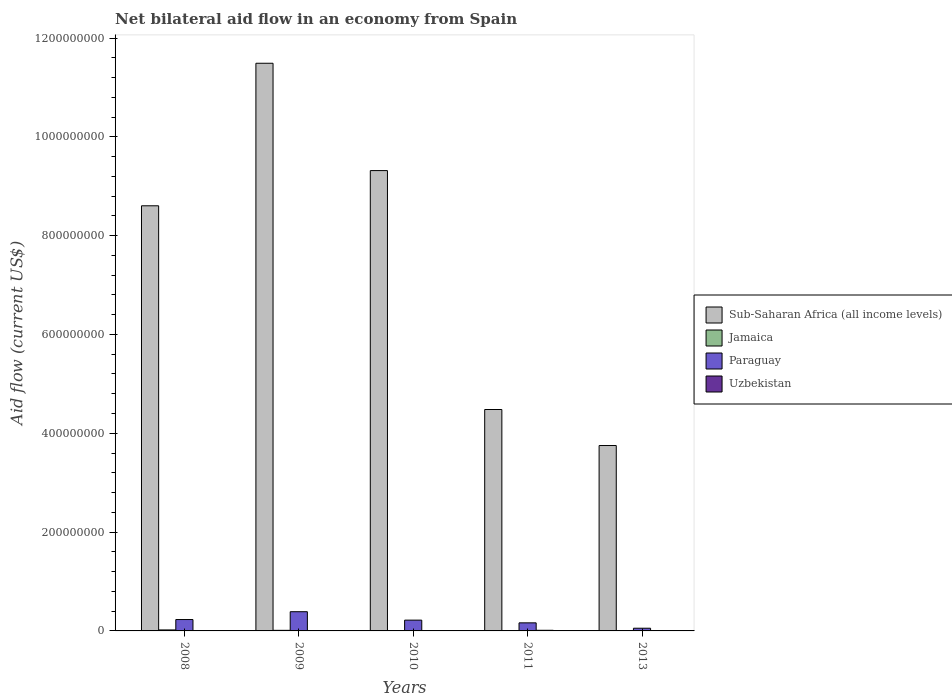Are the number of bars per tick equal to the number of legend labels?
Your response must be concise. Yes. Are the number of bars on each tick of the X-axis equal?
Offer a very short reply. Yes. What is the net bilateral aid flow in Uzbekistan in 2008?
Offer a terse response. 3.60e+05. Across all years, what is the maximum net bilateral aid flow in Paraguay?
Provide a succinct answer. 3.89e+07. Across all years, what is the minimum net bilateral aid flow in Paraguay?
Keep it short and to the point. 5.44e+06. In which year was the net bilateral aid flow in Uzbekistan minimum?
Offer a terse response. 2013. What is the total net bilateral aid flow in Jamaica in the graph?
Your answer should be compact. 4.17e+06. What is the difference between the net bilateral aid flow in Uzbekistan in 2008 and that in 2010?
Provide a succinct answer. 1.30e+05. What is the difference between the net bilateral aid flow in Uzbekistan in 2011 and the net bilateral aid flow in Sub-Saharan Africa (all income levels) in 2010?
Keep it short and to the point. -9.30e+08. What is the average net bilateral aid flow in Paraguay per year?
Make the answer very short. 2.11e+07. In the year 2011, what is the difference between the net bilateral aid flow in Uzbekistan and net bilateral aid flow in Paraguay?
Your response must be concise. -1.51e+07. What is the ratio of the net bilateral aid flow in Sub-Saharan Africa (all income levels) in 2009 to that in 2011?
Keep it short and to the point. 2.56. Is the net bilateral aid flow in Paraguay in 2011 less than that in 2013?
Offer a very short reply. No. Is the difference between the net bilateral aid flow in Uzbekistan in 2009 and 2011 greater than the difference between the net bilateral aid flow in Paraguay in 2009 and 2011?
Keep it short and to the point. No. What is the difference between the highest and the second highest net bilateral aid flow in Paraguay?
Ensure brevity in your answer.  1.59e+07. What is the difference between the highest and the lowest net bilateral aid flow in Paraguay?
Offer a very short reply. 3.34e+07. What does the 4th bar from the left in 2010 represents?
Your answer should be compact. Uzbekistan. What does the 1st bar from the right in 2009 represents?
Offer a very short reply. Uzbekistan. How many bars are there?
Make the answer very short. 20. Are all the bars in the graph horizontal?
Offer a very short reply. No. Are the values on the major ticks of Y-axis written in scientific E-notation?
Give a very brief answer. No. Does the graph contain grids?
Provide a succinct answer. No. How many legend labels are there?
Provide a succinct answer. 4. How are the legend labels stacked?
Make the answer very short. Vertical. What is the title of the graph?
Make the answer very short. Net bilateral aid flow in an economy from Spain. What is the label or title of the X-axis?
Give a very brief answer. Years. What is the Aid flow (current US$) of Sub-Saharan Africa (all income levels) in 2008?
Make the answer very short. 8.60e+08. What is the Aid flow (current US$) in Jamaica in 2008?
Ensure brevity in your answer.  2.02e+06. What is the Aid flow (current US$) in Paraguay in 2008?
Provide a succinct answer. 2.30e+07. What is the Aid flow (current US$) of Uzbekistan in 2008?
Keep it short and to the point. 3.60e+05. What is the Aid flow (current US$) in Sub-Saharan Africa (all income levels) in 2009?
Offer a very short reply. 1.15e+09. What is the Aid flow (current US$) in Jamaica in 2009?
Your answer should be compact. 1.19e+06. What is the Aid flow (current US$) in Paraguay in 2009?
Keep it short and to the point. 3.89e+07. What is the Aid flow (current US$) in Uzbekistan in 2009?
Give a very brief answer. 6.60e+05. What is the Aid flow (current US$) in Sub-Saharan Africa (all income levels) in 2010?
Provide a short and direct response. 9.32e+08. What is the Aid flow (current US$) of Jamaica in 2010?
Provide a short and direct response. 5.10e+05. What is the Aid flow (current US$) in Paraguay in 2010?
Provide a short and direct response. 2.18e+07. What is the Aid flow (current US$) of Sub-Saharan Africa (all income levels) in 2011?
Offer a very short reply. 4.48e+08. What is the Aid flow (current US$) in Paraguay in 2011?
Keep it short and to the point. 1.63e+07. What is the Aid flow (current US$) of Uzbekistan in 2011?
Your response must be concise. 1.27e+06. What is the Aid flow (current US$) in Sub-Saharan Africa (all income levels) in 2013?
Provide a short and direct response. 3.75e+08. What is the Aid flow (current US$) in Jamaica in 2013?
Your answer should be compact. 2.00e+05. What is the Aid flow (current US$) in Paraguay in 2013?
Give a very brief answer. 5.44e+06. What is the Aid flow (current US$) in Uzbekistan in 2013?
Provide a short and direct response. 3.00e+04. Across all years, what is the maximum Aid flow (current US$) in Sub-Saharan Africa (all income levels)?
Your response must be concise. 1.15e+09. Across all years, what is the maximum Aid flow (current US$) in Jamaica?
Your answer should be compact. 2.02e+06. Across all years, what is the maximum Aid flow (current US$) of Paraguay?
Offer a very short reply. 3.89e+07. Across all years, what is the maximum Aid flow (current US$) in Uzbekistan?
Make the answer very short. 1.27e+06. Across all years, what is the minimum Aid flow (current US$) in Sub-Saharan Africa (all income levels)?
Make the answer very short. 3.75e+08. Across all years, what is the minimum Aid flow (current US$) in Paraguay?
Your answer should be very brief. 5.44e+06. What is the total Aid flow (current US$) of Sub-Saharan Africa (all income levels) in the graph?
Ensure brevity in your answer.  3.76e+09. What is the total Aid flow (current US$) of Jamaica in the graph?
Your answer should be very brief. 4.17e+06. What is the total Aid flow (current US$) in Paraguay in the graph?
Make the answer very short. 1.06e+08. What is the total Aid flow (current US$) of Uzbekistan in the graph?
Provide a short and direct response. 2.55e+06. What is the difference between the Aid flow (current US$) of Sub-Saharan Africa (all income levels) in 2008 and that in 2009?
Provide a short and direct response. -2.88e+08. What is the difference between the Aid flow (current US$) of Jamaica in 2008 and that in 2009?
Your answer should be very brief. 8.30e+05. What is the difference between the Aid flow (current US$) of Paraguay in 2008 and that in 2009?
Ensure brevity in your answer.  -1.59e+07. What is the difference between the Aid flow (current US$) of Sub-Saharan Africa (all income levels) in 2008 and that in 2010?
Your response must be concise. -7.13e+07. What is the difference between the Aid flow (current US$) in Jamaica in 2008 and that in 2010?
Give a very brief answer. 1.51e+06. What is the difference between the Aid flow (current US$) of Paraguay in 2008 and that in 2010?
Offer a terse response. 1.19e+06. What is the difference between the Aid flow (current US$) in Sub-Saharan Africa (all income levels) in 2008 and that in 2011?
Offer a terse response. 4.12e+08. What is the difference between the Aid flow (current US$) of Jamaica in 2008 and that in 2011?
Give a very brief answer. 1.77e+06. What is the difference between the Aid flow (current US$) in Paraguay in 2008 and that in 2011?
Ensure brevity in your answer.  6.69e+06. What is the difference between the Aid flow (current US$) in Uzbekistan in 2008 and that in 2011?
Provide a succinct answer. -9.10e+05. What is the difference between the Aid flow (current US$) in Sub-Saharan Africa (all income levels) in 2008 and that in 2013?
Your response must be concise. 4.85e+08. What is the difference between the Aid flow (current US$) of Jamaica in 2008 and that in 2013?
Your answer should be compact. 1.82e+06. What is the difference between the Aid flow (current US$) in Paraguay in 2008 and that in 2013?
Provide a succinct answer. 1.76e+07. What is the difference between the Aid flow (current US$) of Sub-Saharan Africa (all income levels) in 2009 and that in 2010?
Offer a very short reply. 2.17e+08. What is the difference between the Aid flow (current US$) of Jamaica in 2009 and that in 2010?
Your answer should be very brief. 6.80e+05. What is the difference between the Aid flow (current US$) of Paraguay in 2009 and that in 2010?
Offer a terse response. 1.70e+07. What is the difference between the Aid flow (current US$) of Sub-Saharan Africa (all income levels) in 2009 and that in 2011?
Offer a very short reply. 7.01e+08. What is the difference between the Aid flow (current US$) in Jamaica in 2009 and that in 2011?
Your answer should be very brief. 9.40e+05. What is the difference between the Aid flow (current US$) in Paraguay in 2009 and that in 2011?
Provide a short and direct response. 2.26e+07. What is the difference between the Aid flow (current US$) of Uzbekistan in 2009 and that in 2011?
Offer a terse response. -6.10e+05. What is the difference between the Aid flow (current US$) in Sub-Saharan Africa (all income levels) in 2009 and that in 2013?
Ensure brevity in your answer.  7.74e+08. What is the difference between the Aid flow (current US$) of Jamaica in 2009 and that in 2013?
Provide a short and direct response. 9.90e+05. What is the difference between the Aid flow (current US$) in Paraguay in 2009 and that in 2013?
Keep it short and to the point. 3.34e+07. What is the difference between the Aid flow (current US$) in Uzbekistan in 2009 and that in 2013?
Make the answer very short. 6.30e+05. What is the difference between the Aid flow (current US$) in Sub-Saharan Africa (all income levels) in 2010 and that in 2011?
Your response must be concise. 4.84e+08. What is the difference between the Aid flow (current US$) in Jamaica in 2010 and that in 2011?
Offer a terse response. 2.60e+05. What is the difference between the Aid flow (current US$) of Paraguay in 2010 and that in 2011?
Make the answer very short. 5.50e+06. What is the difference between the Aid flow (current US$) of Uzbekistan in 2010 and that in 2011?
Keep it short and to the point. -1.04e+06. What is the difference between the Aid flow (current US$) in Sub-Saharan Africa (all income levels) in 2010 and that in 2013?
Your answer should be compact. 5.56e+08. What is the difference between the Aid flow (current US$) in Jamaica in 2010 and that in 2013?
Make the answer very short. 3.10e+05. What is the difference between the Aid flow (current US$) in Paraguay in 2010 and that in 2013?
Your response must be concise. 1.64e+07. What is the difference between the Aid flow (current US$) in Sub-Saharan Africa (all income levels) in 2011 and that in 2013?
Your answer should be compact. 7.29e+07. What is the difference between the Aid flow (current US$) of Jamaica in 2011 and that in 2013?
Make the answer very short. 5.00e+04. What is the difference between the Aid flow (current US$) in Paraguay in 2011 and that in 2013?
Your answer should be compact. 1.09e+07. What is the difference between the Aid flow (current US$) in Uzbekistan in 2011 and that in 2013?
Your answer should be compact. 1.24e+06. What is the difference between the Aid flow (current US$) in Sub-Saharan Africa (all income levels) in 2008 and the Aid flow (current US$) in Jamaica in 2009?
Offer a terse response. 8.59e+08. What is the difference between the Aid flow (current US$) of Sub-Saharan Africa (all income levels) in 2008 and the Aid flow (current US$) of Paraguay in 2009?
Your answer should be compact. 8.22e+08. What is the difference between the Aid flow (current US$) in Sub-Saharan Africa (all income levels) in 2008 and the Aid flow (current US$) in Uzbekistan in 2009?
Provide a short and direct response. 8.60e+08. What is the difference between the Aid flow (current US$) in Jamaica in 2008 and the Aid flow (current US$) in Paraguay in 2009?
Keep it short and to the point. -3.69e+07. What is the difference between the Aid flow (current US$) of Jamaica in 2008 and the Aid flow (current US$) of Uzbekistan in 2009?
Provide a short and direct response. 1.36e+06. What is the difference between the Aid flow (current US$) in Paraguay in 2008 and the Aid flow (current US$) in Uzbekistan in 2009?
Provide a succinct answer. 2.24e+07. What is the difference between the Aid flow (current US$) in Sub-Saharan Africa (all income levels) in 2008 and the Aid flow (current US$) in Jamaica in 2010?
Your response must be concise. 8.60e+08. What is the difference between the Aid flow (current US$) of Sub-Saharan Africa (all income levels) in 2008 and the Aid flow (current US$) of Paraguay in 2010?
Offer a terse response. 8.39e+08. What is the difference between the Aid flow (current US$) of Sub-Saharan Africa (all income levels) in 2008 and the Aid flow (current US$) of Uzbekistan in 2010?
Offer a terse response. 8.60e+08. What is the difference between the Aid flow (current US$) of Jamaica in 2008 and the Aid flow (current US$) of Paraguay in 2010?
Provide a short and direct response. -1.98e+07. What is the difference between the Aid flow (current US$) in Jamaica in 2008 and the Aid flow (current US$) in Uzbekistan in 2010?
Offer a terse response. 1.79e+06. What is the difference between the Aid flow (current US$) of Paraguay in 2008 and the Aid flow (current US$) of Uzbekistan in 2010?
Your answer should be compact. 2.28e+07. What is the difference between the Aid flow (current US$) in Sub-Saharan Africa (all income levels) in 2008 and the Aid flow (current US$) in Jamaica in 2011?
Provide a short and direct response. 8.60e+08. What is the difference between the Aid flow (current US$) in Sub-Saharan Africa (all income levels) in 2008 and the Aid flow (current US$) in Paraguay in 2011?
Your answer should be compact. 8.44e+08. What is the difference between the Aid flow (current US$) of Sub-Saharan Africa (all income levels) in 2008 and the Aid flow (current US$) of Uzbekistan in 2011?
Offer a terse response. 8.59e+08. What is the difference between the Aid flow (current US$) of Jamaica in 2008 and the Aid flow (current US$) of Paraguay in 2011?
Provide a succinct answer. -1.43e+07. What is the difference between the Aid flow (current US$) of Jamaica in 2008 and the Aid flow (current US$) of Uzbekistan in 2011?
Your answer should be very brief. 7.50e+05. What is the difference between the Aid flow (current US$) in Paraguay in 2008 and the Aid flow (current US$) in Uzbekistan in 2011?
Keep it short and to the point. 2.18e+07. What is the difference between the Aid flow (current US$) of Sub-Saharan Africa (all income levels) in 2008 and the Aid flow (current US$) of Jamaica in 2013?
Your response must be concise. 8.60e+08. What is the difference between the Aid flow (current US$) in Sub-Saharan Africa (all income levels) in 2008 and the Aid flow (current US$) in Paraguay in 2013?
Provide a succinct answer. 8.55e+08. What is the difference between the Aid flow (current US$) of Sub-Saharan Africa (all income levels) in 2008 and the Aid flow (current US$) of Uzbekistan in 2013?
Offer a terse response. 8.60e+08. What is the difference between the Aid flow (current US$) in Jamaica in 2008 and the Aid flow (current US$) in Paraguay in 2013?
Ensure brevity in your answer.  -3.42e+06. What is the difference between the Aid flow (current US$) of Jamaica in 2008 and the Aid flow (current US$) of Uzbekistan in 2013?
Ensure brevity in your answer.  1.99e+06. What is the difference between the Aid flow (current US$) of Paraguay in 2008 and the Aid flow (current US$) of Uzbekistan in 2013?
Your answer should be compact. 2.30e+07. What is the difference between the Aid flow (current US$) of Sub-Saharan Africa (all income levels) in 2009 and the Aid flow (current US$) of Jamaica in 2010?
Make the answer very short. 1.15e+09. What is the difference between the Aid flow (current US$) of Sub-Saharan Africa (all income levels) in 2009 and the Aid flow (current US$) of Paraguay in 2010?
Give a very brief answer. 1.13e+09. What is the difference between the Aid flow (current US$) in Sub-Saharan Africa (all income levels) in 2009 and the Aid flow (current US$) in Uzbekistan in 2010?
Ensure brevity in your answer.  1.15e+09. What is the difference between the Aid flow (current US$) of Jamaica in 2009 and the Aid flow (current US$) of Paraguay in 2010?
Your response must be concise. -2.06e+07. What is the difference between the Aid flow (current US$) in Jamaica in 2009 and the Aid flow (current US$) in Uzbekistan in 2010?
Keep it short and to the point. 9.60e+05. What is the difference between the Aid flow (current US$) of Paraguay in 2009 and the Aid flow (current US$) of Uzbekistan in 2010?
Keep it short and to the point. 3.87e+07. What is the difference between the Aid flow (current US$) of Sub-Saharan Africa (all income levels) in 2009 and the Aid flow (current US$) of Jamaica in 2011?
Provide a short and direct response. 1.15e+09. What is the difference between the Aid flow (current US$) of Sub-Saharan Africa (all income levels) in 2009 and the Aid flow (current US$) of Paraguay in 2011?
Keep it short and to the point. 1.13e+09. What is the difference between the Aid flow (current US$) in Sub-Saharan Africa (all income levels) in 2009 and the Aid flow (current US$) in Uzbekistan in 2011?
Offer a very short reply. 1.15e+09. What is the difference between the Aid flow (current US$) of Jamaica in 2009 and the Aid flow (current US$) of Paraguay in 2011?
Offer a terse response. -1.52e+07. What is the difference between the Aid flow (current US$) of Paraguay in 2009 and the Aid flow (current US$) of Uzbekistan in 2011?
Offer a very short reply. 3.76e+07. What is the difference between the Aid flow (current US$) in Sub-Saharan Africa (all income levels) in 2009 and the Aid flow (current US$) in Jamaica in 2013?
Give a very brief answer. 1.15e+09. What is the difference between the Aid flow (current US$) of Sub-Saharan Africa (all income levels) in 2009 and the Aid flow (current US$) of Paraguay in 2013?
Offer a terse response. 1.14e+09. What is the difference between the Aid flow (current US$) of Sub-Saharan Africa (all income levels) in 2009 and the Aid flow (current US$) of Uzbekistan in 2013?
Provide a short and direct response. 1.15e+09. What is the difference between the Aid flow (current US$) of Jamaica in 2009 and the Aid flow (current US$) of Paraguay in 2013?
Your response must be concise. -4.25e+06. What is the difference between the Aid flow (current US$) in Jamaica in 2009 and the Aid flow (current US$) in Uzbekistan in 2013?
Provide a succinct answer. 1.16e+06. What is the difference between the Aid flow (current US$) of Paraguay in 2009 and the Aid flow (current US$) of Uzbekistan in 2013?
Make the answer very short. 3.89e+07. What is the difference between the Aid flow (current US$) of Sub-Saharan Africa (all income levels) in 2010 and the Aid flow (current US$) of Jamaica in 2011?
Keep it short and to the point. 9.31e+08. What is the difference between the Aid flow (current US$) of Sub-Saharan Africa (all income levels) in 2010 and the Aid flow (current US$) of Paraguay in 2011?
Make the answer very short. 9.15e+08. What is the difference between the Aid flow (current US$) in Sub-Saharan Africa (all income levels) in 2010 and the Aid flow (current US$) in Uzbekistan in 2011?
Make the answer very short. 9.30e+08. What is the difference between the Aid flow (current US$) of Jamaica in 2010 and the Aid flow (current US$) of Paraguay in 2011?
Your answer should be very brief. -1.58e+07. What is the difference between the Aid flow (current US$) in Jamaica in 2010 and the Aid flow (current US$) in Uzbekistan in 2011?
Offer a very short reply. -7.60e+05. What is the difference between the Aid flow (current US$) in Paraguay in 2010 and the Aid flow (current US$) in Uzbekistan in 2011?
Offer a very short reply. 2.06e+07. What is the difference between the Aid flow (current US$) in Sub-Saharan Africa (all income levels) in 2010 and the Aid flow (current US$) in Jamaica in 2013?
Offer a very short reply. 9.32e+08. What is the difference between the Aid flow (current US$) of Sub-Saharan Africa (all income levels) in 2010 and the Aid flow (current US$) of Paraguay in 2013?
Offer a very short reply. 9.26e+08. What is the difference between the Aid flow (current US$) in Sub-Saharan Africa (all income levels) in 2010 and the Aid flow (current US$) in Uzbekistan in 2013?
Ensure brevity in your answer.  9.32e+08. What is the difference between the Aid flow (current US$) in Jamaica in 2010 and the Aid flow (current US$) in Paraguay in 2013?
Provide a short and direct response. -4.93e+06. What is the difference between the Aid flow (current US$) of Paraguay in 2010 and the Aid flow (current US$) of Uzbekistan in 2013?
Ensure brevity in your answer.  2.18e+07. What is the difference between the Aid flow (current US$) in Sub-Saharan Africa (all income levels) in 2011 and the Aid flow (current US$) in Jamaica in 2013?
Give a very brief answer. 4.48e+08. What is the difference between the Aid flow (current US$) of Sub-Saharan Africa (all income levels) in 2011 and the Aid flow (current US$) of Paraguay in 2013?
Your answer should be compact. 4.43e+08. What is the difference between the Aid flow (current US$) of Sub-Saharan Africa (all income levels) in 2011 and the Aid flow (current US$) of Uzbekistan in 2013?
Keep it short and to the point. 4.48e+08. What is the difference between the Aid flow (current US$) of Jamaica in 2011 and the Aid flow (current US$) of Paraguay in 2013?
Provide a short and direct response. -5.19e+06. What is the difference between the Aid flow (current US$) of Jamaica in 2011 and the Aid flow (current US$) of Uzbekistan in 2013?
Ensure brevity in your answer.  2.20e+05. What is the difference between the Aid flow (current US$) of Paraguay in 2011 and the Aid flow (current US$) of Uzbekistan in 2013?
Your response must be concise. 1.63e+07. What is the average Aid flow (current US$) in Sub-Saharan Africa (all income levels) per year?
Offer a very short reply. 7.53e+08. What is the average Aid flow (current US$) in Jamaica per year?
Provide a succinct answer. 8.34e+05. What is the average Aid flow (current US$) in Paraguay per year?
Your answer should be compact. 2.11e+07. What is the average Aid flow (current US$) of Uzbekistan per year?
Provide a short and direct response. 5.10e+05. In the year 2008, what is the difference between the Aid flow (current US$) in Sub-Saharan Africa (all income levels) and Aid flow (current US$) in Jamaica?
Provide a succinct answer. 8.58e+08. In the year 2008, what is the difference between the Aid flow (current US$) in Sub-Saharan Africa (all income levels) and Aid flow (current US$) in Paraguay?
Your answer should be compact. 8.37e+08. In the year 2008, what is the difference between the Aid flow (current US$) in Sub-Saharan Africa (all income levels) and Aid flow (current US$) in Uzbekistan?
Your response must be concise. 8.60e+08. In the year 2008, what is the difference between the Aid flow (current US$) of Jamaica and Aid flow (current US$) of Paraguay?
Your answer should be very brief. -2.10e+07. In the year 2008, what is the difference between the Aid flow (current US$) in Jamaica and Aid flow (current US$) in Uzbekistan?
Offer a terse response. 1.66e+06. In the year 2008, what is the difference between the Aid flow (current US$) of Paraguay and Aid flow (current US$) of Uzbekistan?
Your answer should be very brief. 2.27e+07. In the year 2009, what is the difference between the Aid flow (current US$) in Sub-Saharan Africa (all income levels) and Aid flow (current US$) in Jamaica?
Your response must be concise. 1.15e+09. In the year 2009, what is the difference between the Aid flow (current US$) in Sub-Saharan Africa (all income levels) and Aid flow (current US$) in Paraguay?
Keep it short and to the point. 1.11e+09. In the year 2009, what is the difference between the Aid flow (current US$) of Sub-Saharan Africa (all income levels) and Aid flow (current US$) of Uzbekistan?
Your answer should be very brief. 1.15e+09. In the year 2009, what is the difference between the Aid flow (current US$) of Jamaica and Aid flow (current US$) of Paraguay?
Make the answer very short. -3.77e+07. In the year 2009, what is the difference between the Aid flow (current US$) in Jamaica and Aid flow (current US$) in Uzbekistan?
Offer a very short reply. 5.30e+05. In the year 2009, what is the difference between the Aid flow (current US$) in Paraguay and Aid flow (current US$) in Uzbekistan?
Provide a succinct answer. 3.82e+07. In the year 2010, what is the difference between the Aid flow (current US$) of Sub-Saharan Africa (all income levels) and Aid flow (current US$) of Jamaica?
Ensure brevity in your answer.  9.31e+08. In the year 2010, what is the difference between the Aid flow (current US$) in Sub-Saharan Africa (all income levels) and Aid flow (current US$) in Paraguay?
Offer a terse response. 9.10e+08. In the year 2010, what is the difference between the Aid flow (current US$) of Sub-Saharan Africa (all income levels) and Aid flow (current US$) of Uzbekistan?
Your answer should be very brief. 9.31e+08. In the year 2010, what is the difference between the Aid flow (current US$) of Jamaica and Aid flow (current US$) of Paraguay?
Provide a short and direct response. -2.13e+07. In the year 2010, what is the difference between the Aid flow (current US$) in Jamaica and Aid flow (current US$) in Uzbekistan?
Offer a very short reply. 2.80e+05. In the year 2010, what is the difference between the Aid flow (current US$) of Paraguay and Aid flow (current US$) of Uzbekistan?
Keep it short and to the point. 2.16e+07. In the year 2011, what is the difference between the Aid flow (current US$) in Sub-Saharan Africa (all income levels) and Aid flow (current US$) in Jamaica?
Provide a succinct answer. 4.48e+08. In the year 2011, what is the difference between the Aid flow (current US$) in Sub-Saharan Africa (all income levels) and Aid flow (current US$) in Paraguay?
Give a very brief answer. 4.32e+08. In the year 2011, what is the difference between the Aid flow (current US$) of Sub-Saharan Africa (all income levels) and Aid flow (current US$) of Uzbekistan?
Make the answer very short. 4.47e+08. In the year 2011, what is the difference between the Aid flow (current US$) of Jamaica and Aid flow (current US$) of Paraguay?
Keep it short and to the point. -1.61e+07. In the year 2011, what is the difference between the Aid flow (current US$) in Jamaica and Aid flow (current US$) in Uzbekistan?
Your response must be concise. -1.02e+06. In the year 2011, what is the difference between the Aid flow (current US$) in Paraguay and Aid flow (current US$) in Uzbekistan?
Offer a very short reply. 1.51e+07. In the year 2013, what is the difference between the Aid flow (current US$) of Sub-Saharan Africa (all income levels) and Aid flow (current US$) of Jamaica?
Provide a short and direct response. 3.75e+08. In the year 2013, what is the difference between the Aid flow (current US$) in Sub-Saharan Africa (all income levels) and Aid flow (current US$) in Paraguay?
Make the answer very short. 3.70e+08. In the year 2013, what is the difference between the Aid flow (current US$) in Sub-Saharan Africa (all income levels) and Aid flow (current US$) in Uzbekistan?
Ensure brevity in your answer.  3.75e+08. In the year 2013, what is the difference between the Aid flow (current US$) in Jamaica and Aid flow (current US$) in Paraguay?
Keep it short and to the point. -5.24e+06. In the year 2013, what is the difference between the Aid flow (current US$) of Paraguay and Aid flow (current US$) of Uzbekistan?
Your response must be concise. 5.41e+06. What is the ratio of the Aid flow (current US$) of Sub-Saharan Africa (all income levels) in 2008 to that in 2009?
Keep it short and to the point. 0.75. What is the ratio of the Aid flow (current US$) of Jamaica in 2008 to that in 2009?
Keep it short and to the point. 1.7. What is the ratio of the Aid flow (current US$) of Paraguay in 2008 to that in 2009?
Provide a short and direct response. 0.59. What is the ratio of the Aid flow (current US$) in Uzbekistan in 2008 to that in 2009?
Ensure brevity in your answer.  0.55. What is the ratio of the Aid flow (current US$) in Sub-Saharan Africa (all income levels) in 2008 to that in 2010?
Offer a very short reply. 0.92. What is the ratio of the Aid flow (current US$) of Jamaica in 2008 to that in 2010?
Your response must be concise. 3.96. What is the ratio of the Aid flow (current US$) of Paraguay in 2008 to that in 2010?
Your answer should be compact. 1.05. What is the ratio of the Aid flow (current US$) of Uzbekistan in 2008 to that in 2010?
Provide a short and direct response. 1.57. What is the ratio of the Aid flow (current US$) in Sub-Saharan Africa (all income levels) in 2008 to that in 2011?
Offer a terse response. 1.92. What is the ratio of the Aid flow (current US$) of Jamaica in 2008 to that in 2011?
Your answer should be compact. 8.08. What is the ratio of the Aid flow (current US$) of Paraguay in 2008 to that in 2011?
Provide a succinct answer. 1.41. What is the ratio of the Aid flow (current US$) in Uzbekistan in 2008 to that in 2011?
Provide a short and direct response. 0.28. What is the ratio of the Aid flow (current US$) of Sub-Saharan Africa (all income levels) in 2008 to that in 2013?
Make the answer very short. 2.29. What is the ratio of the Aid flow (current US$) of Jamaica in 2008 to that in 2013?
Offer a very short reply. 10.1. What is the ratio of the Aid flow (current US$) in Paraguay in 2008 to that in 2013?
Offer a very short reply. 4.23. What is the ratio of the Aid flow (current US$) in Uzbekistan in 2008 to that in 2013?
Offer a very short reply. 12. What is the ratio of the Aid flow (current US$) of Sub-Saharan Africa (all income levels) in 2009 to that in 2010?
Your answer should be compact. 1.23. What is the ratio of the Aid flow (current US$) of Jamaica in 2009 to that in 2010?
Give a very brief answer. 2.33. What is the ratio of the Aid flow (current US$) in Paraguay in 2009 to that in 2010?
Your response must be concise. 1.78. What is the ratio of the Aid flow (current US$) of Uzbekistan in 2009 to that in 2010?
Make the answer very short. 2.87. What is the ratio of the Aid flow (current US$) of Sub-Saharan Africa (all income levels) in 2009 to that in 2011?
Provide a short and direct response. 2.56. What is the ratio of the Aid flow (current US$) in Jamaica in 2009 to that in 2011?
Provide a short and direct response. 4.76. What is the ratio of the Aid flow (current US$) of Paraguay in 2009 to that in 2011?
Provide a short and direct response. 2.38. What is the ratio of the Aid flow (current US$) in Uzbekistan in 2009 to that in 2011?
Your response must be concise. 0.52. What is the ratio of the Aid flow (current US$) of Sub-Saharan Africa (all income levels) in 2009 to that in 2013?
Your response must be concise. 3.06. What is the ratio of the Aid flow (current US$) of Jamaica in 2009 to that in 2013?
Ensure brevity in your answer.  5.95. What is the ratio of the Aid flow (current US$) in Paraguay in 2009 to that in 2013?
Your answer should be compact. 7.15. What is the ratio of the Aid flow (current US$) of Sub-Saharan Africa (all income levels) in 2010 to that in 2011?
Your answer should be very brief. 2.08. What is the ratio of the Aid flow (current US$) of Jamaica in 2010 to that in 2011?
Your answer should be very brief. 2.04. What is the ratio of the Aid flow (current US$) in Paraguay in 2010 to that in 2011?
Provide a succinct answer. 1.34. What is the ratio of the Aid flow (current US$) in Uzbekistan in 2010 to that in 2011?
Provide a succinct answer. 0.18. What is the ratio of the Aid flow (current US$) of Sub-Saharan Africa (all income levels) in 2010 to that in 2013?
Give a very brief answer. 2.48. What is the ratio of the Aid flow (current US$) of Jamaica in 2010 to that in 2013?
Provide a short and direct response. 2.55. What is the ratio of the Aid flow (current US$) in Paraguay in 2010 to that in 2013?
Ensure brevity in your answer.  4.01. What is the ratio of the Aid flow (current US$) of Uzbekistan in 2010 to that in 2013?
Provide a succinct answer. 7.67. What is the ratio of the Aid flow (current US$) in Sub-Saharan Africa (all income levels) in 2011 to that in 2013?
Your response must be concise. 1.19. What is the ratio of the Aid flow (current US$) in Paraguay in 2011 to that in 2013?
Ensure brevity in your answer.  3. What is the ratio of the Aid flow (current US$) of Uzbekistan in 2011 to that in 2013?
Your response must be concise. 42.33. What is the difference between the highest and the second highest Aid flow (current US$) in Sub-Saharan Africa (all income levels)?
Offer a terse response. 2.17e+08. What is the difference between the highest and the second highest Aid flow (current US$) of Jamaica?
Your answer should be compact. 8.30e+05. What is the difference between the highest and the second highest Aid flow (current US$) in Paraguay?
Ensure brevity in your answer.  1.59e+07. What is the difference between the highest and the lowest Aid flow (current US$) in Sub-Saharan Africa (all income levels)?
Provide a short and direct response. 7.74e+08. What is the difference between the highest and the lowest Aid flow (current US$) in Jamaica?
Your response must be concise. 1.82e+06. What is the difference between the highest and the lowest Aid flow (current US$) of Paraguay?
Make the answer very short. 3.34e+07. What is the difference between the highest and the lowest Aid flow (current US$) in Uzbekistan?
Make the answer very short. 1.24e+06. 